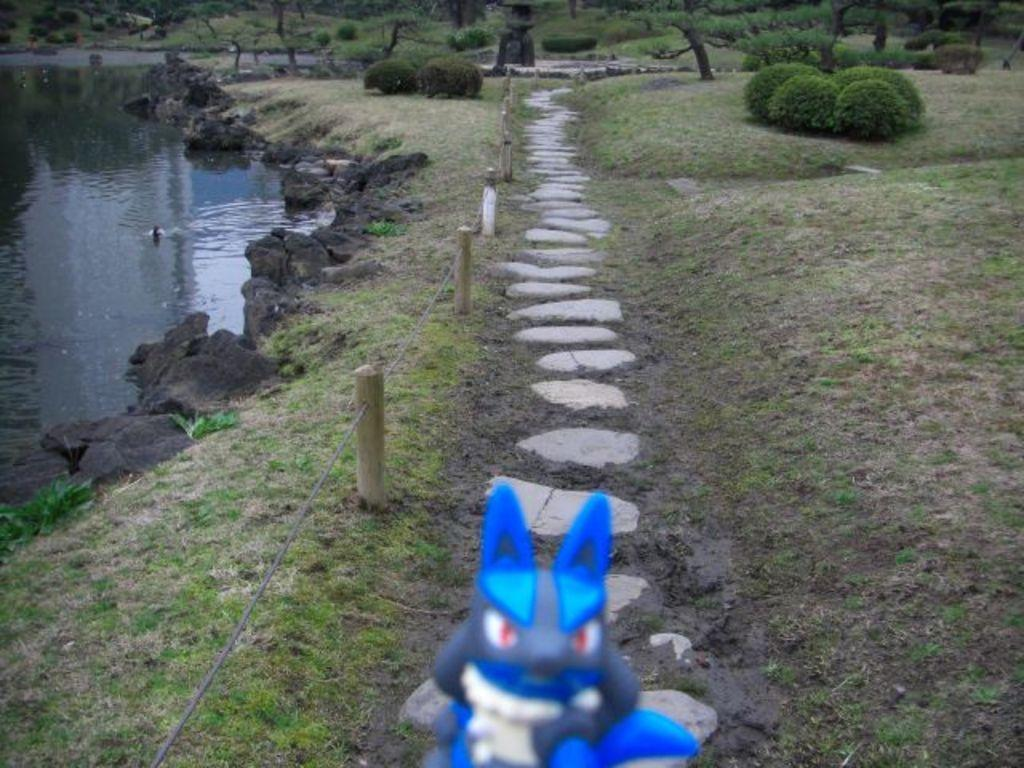What type of living organisms can be seen in the image? Plants can be seen in the image. What body of water is visible on the left side of the image? There is a lake on the left side of the image. What structure is located in the middle of the image? There is a fence in the middle of the image. What object can be found at the bottom of the image? There is a toy at the bottom of the image. What type of chess piece is located near the fence in the image? There is no chess piece present in the image. What voice can be heard coming from the toy at the bottom of the image? The image is silent, and there is no voice coming from the toy. 